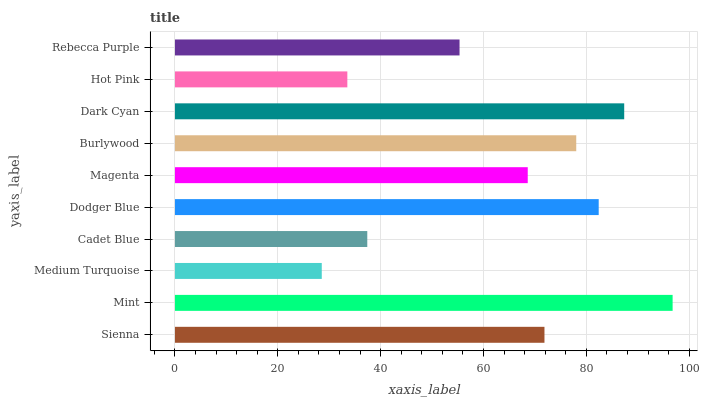Is Medium Turquoise the minimum?
Answer yes or no. Yes. Is Mint the maximum?
Answer yes or no. Yes. Is Mint the minimum?
Answer yes or no. No. Is Medium Turquoise the maximum?
Answer yes or no. No. Is Mint greater than Medium Turquoise?
Answer yes or no. Yes. Is Medium Turquoise less than Mint?
Answer yes or no. Yes. Is Medium Turquoise greater than Mint?
Answer yes or no. No. Is Mint less than Medium Turquoise?
Answer yes or no. No. Is Sienna the high median?
Answer yes or no. Yes. Is Magenta the low median?
Answer yes or no. Yes. Is Magenta the high median?
Answer yes or no. No. Is Dark Cyan the low median?
Answer yes or no. No. 